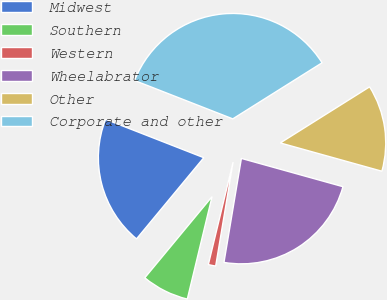<chart> <loc_0><loc_0><loc_500><loc_500><pie_chart><fcel>Midwest<fcel>Southern<fcel>Western<fcel>Wheelabrator<fcel>Other<fcel>Corporate and other<nl><fcel>19.92%<fcel>7.24%<fcel>1.13%<fcel>23.32%<fcel>13.25%<fcel>35.14%<nl></chart> 